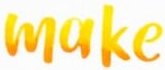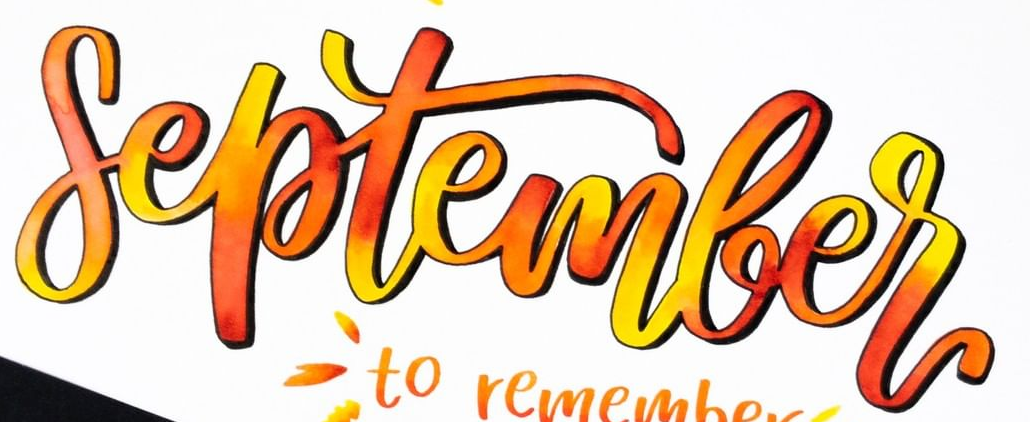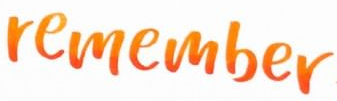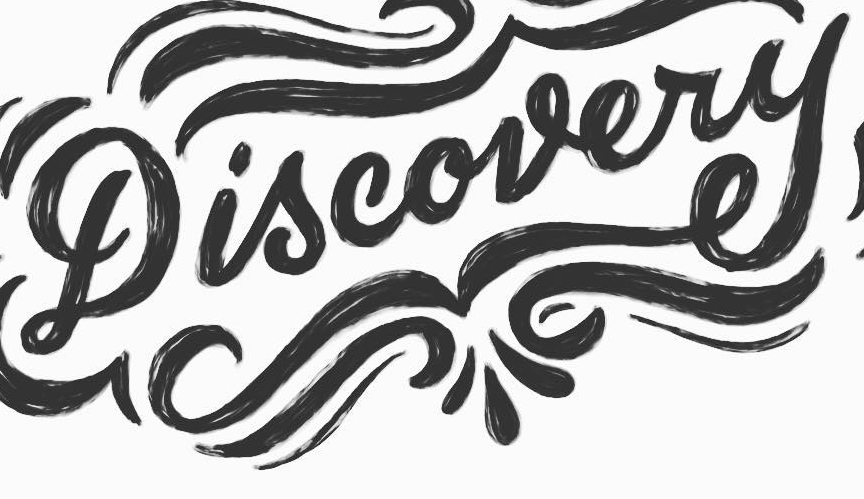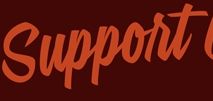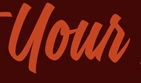Read the text content from these images in order, separated by a semicolon. make; September; remember; Discovery; Support; Your 